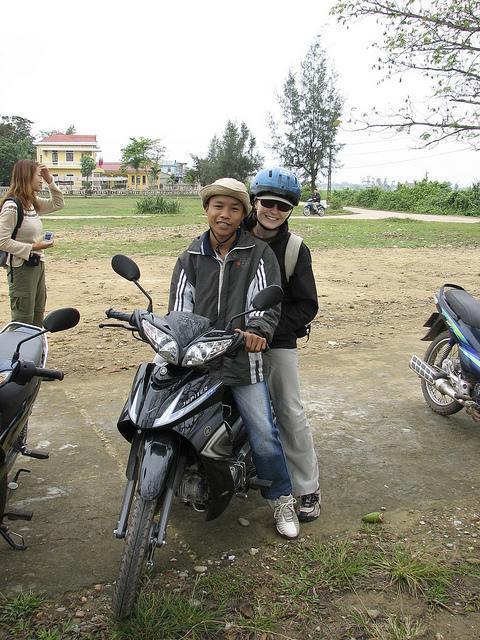How many people are there?
Give a very brief answer. 3. How many motorcycles are there?
Give a very brief answer. 3. How many birds are standing on the sidewalk?
Give a very brief answer. 0. 